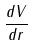<formula> <loc_0><loc_0><loc_500><loc_500>\frac { d V } { d r }</formula> 